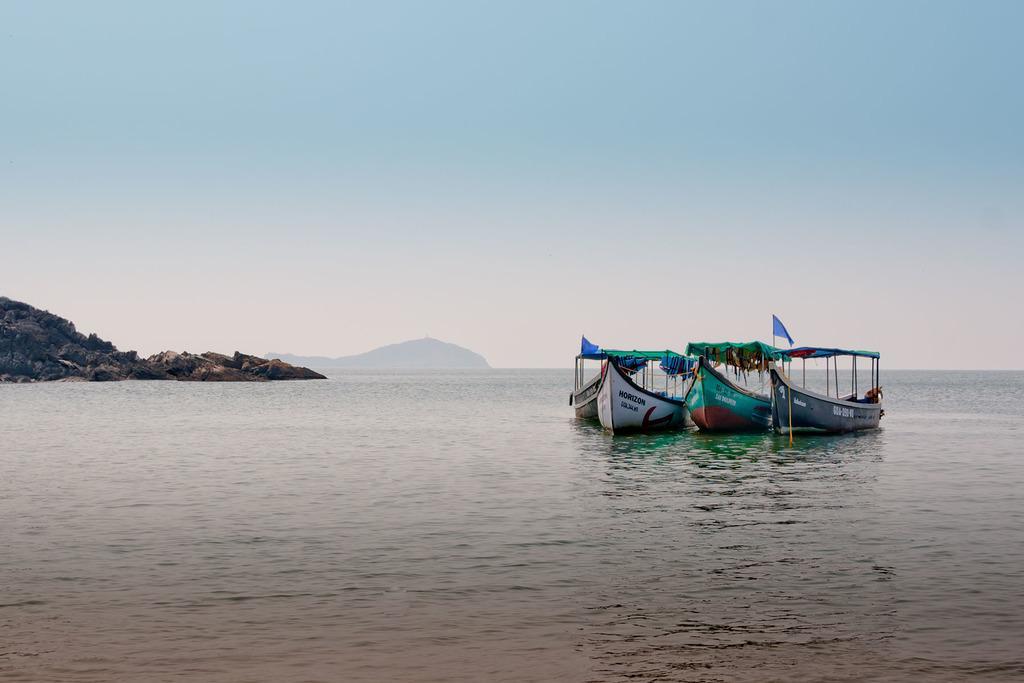In one or two sentences, can you explain what this image depicts? At the bottom of the image there is water. On the water there are boats with poles and flags. On the left corner of the image there are hills. At the top of the image there is sky. 